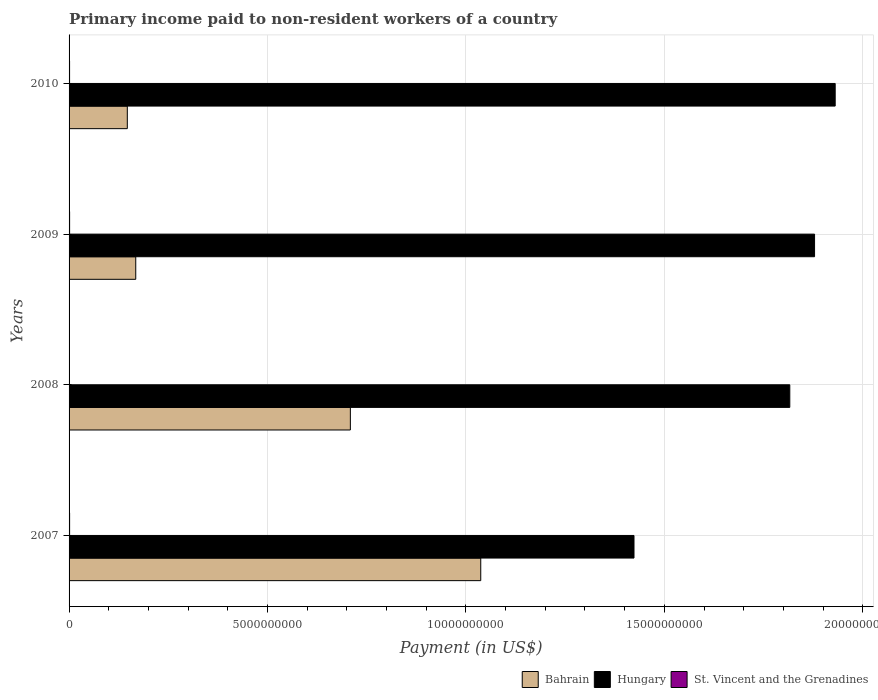Are the number of bars per tick equal to the number of legend labels?
Ensure brevity in your answer.  Yes. Are the number of bars on each tick of the Y-axis equal?
Your answer should be compact. Yes. How many bars are there on the 4th tick from the bottom?
Keep it short and to the point. 3. What is the amount paid to workers in St. Vincent and the Grenadines in 2010?
Provide a short and direct response. 1.27e+07. Across all years, what is the maximum amount paid to workers in St. Vincent and the Grenadines?
Offer a very short reply. 1.37e+07. Across all years, what is the minimum amount paid to workers in Hungary?
Offer a terse response. 1.42e+1. What is the total amount paid to workers in Bahrain in the graph?
Your response must be concise. 2.06e+1. What is the difference between the amount paid to workers in Hungary in 2007 and that in 2008?
Make the answer very short. -3.93e+09. What is the difference between the amount paid to workers in St. Vincent and the Grenadines in 2010 and the amount paid to workers in Hungary in 2008?
Offer a terse response. -1.81e+1. What is the average amount paid to workers in St. Vincent and the Grenadines per year?
Keep it short and to the point. 1.25e+07. In the year 2007, what is the difference between the amount paid to workers in Bahrain and amount paid to workers in St. Vincent and the Grenadines?
Make the answer very short. 1.04e+1. What is the ratio of the amount paid to workers in St. Vincent and the Grenadines in 2007 to that in 2010?
Ensure brevity in your answer.  1.06. Is the amount paid to workers in Bahrain in 2008 less than that in 2010?
Make the answer very short. No. Is the difference between the amount paid to workers in Bahrain in 2007 and 2010 greater than the difference between the amount paid to workers in St. Vincent and the Grenadines in 2007 and 2010?
Make the answer very short. Yes. What is the difference between the highest and the second highest amount paid to workers in St. Vincent and the Grenadines?
Keep it short and to the point. 2.77e+05. What is the difference between the highest and the lowest amount paid to workers in Hungary?
Make the answer very short. 5.07e+09. In how many years, is the amount paid to workers in Hungary greater than the average amount paid to workers in Hungary taken over all years?
Your answer should be very brief. 3. Is the sum of the amount paid to workers in St. Vincent and the Grenadines in 2009 and 2010 greater than the maximum amount paid to workers in Hungary across all years?
Provide a short and direct response. No. What does the 2nd bar from the top in 2010 represents?
Provide a succinct answer. Hungary. What does the 3rd bar from the bottom in 2009 represents?
Ensure brevity in your answer.  St. Vincent and the Grenadines. Is it the case that in every year, the sum of the amount paid to workers in Bahrain and amount paid to workers in St. Vincent and the Grenadines is greater than the amount paid to workers in Hungary?
Provide a short and direct response. No. How many bars are there?
Give a very brief answer. 12. How many years are there in the graph?
Your response must be concise. 4. What is the difference between two consecutive major ticks on the X-axis?
Ensure brevity in your answer.  5.00e+09. Are the values on the major ticks of X-axis written in scientific E-notation?
Provide a short and direct response. No. Does the graph contain grids?
Your answer should be compact. Yes. What is the title of the graph?
Provide a short and direct response. Primary income paid to non-resident workers of a country. What is the label or title of the X-axis?
Provide a succinct answer. Payment (in US$). What is the label or title of the Y-axis?
Make the answer very short. Years. What is the Payment (in US$) in Bahrain in 2007?
Your answer should be compact. 1.04e+1. What is the Payment (in US$) of Hungary in 2007?
Keep it short and to the point. 1.42e+1. What is the Payment (in US$) in St. Vincent and the Grenadines in 2007?
Your answer should be very brief. 1.34e+07. What is the Payment (in US$) in Bahrain in 2008?
Your answer should be compact. 7.09e+09. What is the Payment (in US$) in Hungary in 2008?
Make the answer very short. 1.82e+1. What is the Payment (in US$) of St. Vincent and the Grenadines in 2008?
Your answer should be compact. 1.01e+07. What is the Payment (in US$) of Bahrain in 2009?
Keep it short and to the point. 1.68e+09. What is the Payment (in US$) of Hungary in 2009?
Keep it short and to the point. 1.88e+1. What is the Payment (in US$) of St. Vincent and the Grenadines in 2009?
Your answer should be compact. 1.37e+07. What is the Payment (in US$) of Bahrain in 2010?
Offer a very short reply. 1.47e+09. What is the Payment (in US$) of Hungary in 2010?
Keep it short and to the point. 1.93e+1. What is the Payment (in US$) in St. Vincent and the Grenadines in 2010?
Keep it short and to the point. 1.27e+07. Across all years, what is the maximum Payment (in US$) in Bahrain?
Your response must be concise. 1.04e+1. Across all years, what is the maximum Payment (in US$) of Hungary?
Keep it short and to the point. 1.93e+1. Across all years, what is the maximum Payment (in US$) in St. Vincent and the Grenadines?
Your response must be concise. 1.37e+07. Across all years, what is the minimum Payment (in US$) in Bahrain?
Offer a terse response. 1.47e+09. Across all years, what is the minimum Payment (in US$) of Hungary?
Your answer should be very brief. 1.42e+1. Across all years, what is the minimum Payment (in US$) of St. Vincent and the Grenadines?
Offer a very short reply. 1.01e+07. What is the total Payment (in US$) of Bahrain in the graph?
Your answer should be very brief. 2.06e+1. What is the total Payment (in US$) of Hungary in the graph?
Offer a terse response. 7.05e+1. What is the total Payment (in US$) in St. Vincent and the Grenadines in the graph?
Make the answer very short. 4.99e+07. What is the difference between the Payment (in US$) of Bahrain in 2007 and that in 2008?
Your answer should be very brief. 3.29e+09. What is the difference between the Payment (in US$) in Hungary in 2007 and that in 2008?
Offer a very short reply. -3.93e+09. What is the difference between the Payment (in US$) of St. Vincent and the Grenadines in 2007 and that in 2008?
Your answer should be very brief. 3.29e+06. What is the difference between the Payment (in US$) of Bahrain in 2007 and that in 2009?
Provide a succinct answer. 8.69e+09. What is the difference between the Payment (in US$) in Hungary in 2007 and that in 2009?
Provide a succinct answer. -4.55e+09. What is the difference between the Payment (in US$) of St. Vincent and the Grenadines in 2007 and that in 2009?
Your answer should be compact. -2.77e+05. What is the difference between the Payment (in US$) of Bahrain in 2007 and that in 2010?
Your answer should be very brief. 8.91e+09. What is the difference between the Payment (in US$) in Hungary in 2007 and that in 2010?
Ensure brevity in your answer.  -5.07e+09. What is the difference between the Payment (in US$) in St. Vincent and the Grenadines in 2007 and that in 2010?
Ensure brevity in your answer.  7.36e+05. What is the difference between the Payment (in US$) in Bahrain in 2008 and that in 2009?
Provide a succinct answer. 5.41e+09. What is the difference between the Payment (in US$) of Hungary in 2008 and that in 2009?
Your answer should be very brief. -6.24e+08. What is the difference between the Payment (in US$) of St. Vincent and the Grenadines in 2008 and that in 2009?
Make the answer very short. -3.57e+06. What is the difference between the Payment (in US$) of Bahrain in 2008 and that in 2010?
Your answer should be very brief. 5.62e+09. What is the difference between the Payment (in US$) in Hungary in 2008 and that in 2010?
Offer a terse response. -1.14e+09. What is the difference between the Payment (in US$) in St. Vincent and the Grenadines in 2008 and that in 2010?
Provide a succinct answer. -2.55e+06. What is the difference between the Payment (in US$) of Bahrain in 2009 and that in 2010?
Provide a short and direct response. 2.13e+08. What is the difference between the Payment (in US$) of Hungary in 2009 and that in 2010?
Your answer should be compact. -5.20e+08. What is the difference between the Payment (in US$) of St. Vincent and the Grenadines in 2009 and that in 2010?
Give a very brief answer. 1.01e+06. What is the difference between the Payment (in US$) of Bahrain in 2007 and the Payment (in US$) of Hungary in 2008?
Provide a succinct answer. -7.79e+09. What is the difference between the Payment (in US$) of Bahrain in 2007 and the Payment (in US$) of St. Vincent and the Grenadines in 2008?
Provide a short and direct response. 1.04e+1. What is the difference between the Payment (in US$) of Hungary in 2007 and the Payment (in US$) of St. Vincent and the Grenadines in 2008?
Your answer should be very brief. 1.42e+1. What is the difference between the Payment (in US$) of Bahrain in 2007 and the Payment (in US$) of Hungary in 2009?
Offer a terse response. -8.41e+09. What is the difference between the Payment (in US$) in Bahrain in 2007 and the Payment (in US$) in St. Vincent and the Grenadines in 2009?
Your response must be concise. 1.04e+1. What is the difference between the Payment (in US$) in Hungary in 2007 and the Payment (in US$) in St. Vincent and the Grenadines in 2009?
Your answer should be compact. 1.42e+1. What is the difference between the Payment (in US$) of Bahrain in 2007 and the Payment (in US$) of Hungary in 2010?
Your answer should be very brief. -8.93e+09. What is the difference between the Payment (in US$) of Bahrain in 2007 and the Payment (in US$) of St. Vincent and the Grenadines in 2010?
Offer a terse response. 1.04e+1. What is the difference between the Payment (in US$) of Hungary in 2007 and the Payment (in US$) of St. Vincent and the Grenadines in 2010?
Offer a terse response. 1.42e+1. What is the difference between the Payment (in US$) in Bahrain in 2008 and the Payment (in US$) in Hungary in 2009?
Offer a very short reply. -1.17e+1. What is the difference between the Payment (in US$) of Bahrain in 2008 and the Payment (in US$) of St. Vincent and the Grenadines in 2009?
Provide a succinct answer. 7.07e+09. What is the difference between the Payment (in US$) of Hungary in 2008 and the Payment (in US$) of St. Vincent and the Grenadines in 2009?
Offer a very short reply. 1.81e+1. What is the difference between the Payment (in US$) of Bahrain in 2008 and the Payment (in US$) of Hungary in 2010?
Offer a very short reply. -1.22e+1. What is the difference between the Payment (in US$) of Bahrain in 2008 and the Payment (in US$) of St. Vincent and the Grenadines in 2010?
Keep it short and to the point. 7.08e+09. What is the difference between the Payment (in US$) of Hungary in 2008 and the Payment (in US$) of St. Vincent and the Grenadines in 2010?
Provide a succinct answer. 1.81e+1. What is the difference between the Payment (in US$) of Bahrain in 2009 and the Payment (in US$) of Hungary in 2010?
Provide a short and direct response. -1.76e+1. What is the difference between the Payment (in US$) of Bahrain in 2009 and the Payment (in US$) of St. Vincent and the Grenadines in 2010?
Provide a short and direct response. 1.67e+09. What is the difference between the Payment (in US$) of Hungary in 2009 and the Payment (in US$) of St. Vincent and the Grenadines in 2010?
Provide a succinct answer. 1.88e+1. What is the average Payment (in US$) in Bahrain per year?
Your answer should be very brief. 5.15e+09. What is the average Payment (in US$) in Hungary per year?
Offer a very short reply. 1.76e+1. What is the average Payment (in US$) in St. Vincent and the Grenadines per year?
Your answer should be very brief. 1.25e+07. In the year 2007, what is the difference between the Payment (in US$) of Bahrain and Payment (in US$) of Hungary?
Provide a succinct answer. -3.86e+09. In the year 2007, what is the difference between the Payment (in US$) in Bahrain and Payment (in US$) in St. Vincent and the Grenadines?
Ensure brevity in your answer.  1.04e+1. In the year 2007, what is the difference between the Payment (in US$) in Hungary and Payment (in US$) in St. Vincent and the Grenadines?
Provide a short and direct response. 1.42e+1. In the year 2008, what is the difference between the Payment (in US$) in Bahrain and Payment (in US$) in Hungary?
Your answer should be compact. -1.11e+1. In the year 2008, what is the difference between the Payment (in US$) of Bahrain and Payment (in US$) of St. Vincent and the Grenadines?
Your response must be concise. 7.08e+09. In the year 2008, what is the difference between the Payment (in US$) of Hungary and Payment (in US$) of St. Vincent and the Grenadines?
Provide a short and direct response. 1.82e+1. In the year 2009, what is the difference between the Payment (in US$) of Bahrain and Payment (in US$) of Hungary?
Your response must be concise. -1.71e+1. In the year 2009, what is the difference between the Payment (in US$) in Bahrain and Payment (in US$) in St. Vincent and the Grenadines?
Provide a succinct answer. 1.67e+09. In the year 2009, what is the difference between the Payment (in US$) in Hungary and Payment (in US$) in St. Vincent and the Grenadines?
Give a very brief answer. 1.88e+1. In the year 2010, what is the difference between the Payment (in US$) of Bahrain and Payment (in US$) of Hungary?
Your response must be concise. -1.78e+1. In the year 2010, what is the difference between the Payment (in US$) in Bahrain and Payment (in US$) in St. Vincent and the Grenadines?
Offer a very short reply. 1.45e+09. In the year 2010, what is the difference between the Payment (in US$) of Hungary and Payment (in US$) of St. Vincent and the Grenadines?
Ensure brevity in your answer.  1.93e+1. What is the ratio of the Payment (in US$) of Bahrain in 2007 to that in 2008?
Provide a short and direct response. 1.46. What is the ratio of the Payment (in US$) in Hungary in 2007 to that in 2008?
Give a very brief answer. 0.78. What is the ratio of the Payment (in US$) in St. Vincent and the Grenadines in 2007 to that in 2008?
Offer a very short reply. 1.33. What is the ratio of the Payment (in US$) of Bahrain in 2007 to that in 2009?
Offer a very short reply. 6.17. What is the ratio of the Payment (in US$) in Hungary in 2007 to that in 2009?
Ensure brevity in your answer.  0.76. What is the ratio of the Payment (in US$) of St. Vincent and the Grenadines in 2007 to that in 2009?
Give a very brief answer. 0.98. What is the ratio of the Payment (in US$) in Bahrain in 2007 to that in 2010?
Give a very brief answer. 7.07. What is the ratio of the Payment (in US$) in Hungary in 2007 to that in 2010?
Make the answer very short. 0.74. What is the ratio of the Payment (in US$) in St. Vincent and the Grenadines in 2007 to that in 2010?
Your response must be concise. 1.06. What is the ratio of the Payment (in US$) in Bahrain in 2008 to that in 2009?
Your response must be concise. 4.22. What is the ratio of the Payment (in US$) of Hungary in 2008 to that in 2009?
Your answer should be compact. 0.97. What is the ratio of the Payment (in US$) in St. Vincent and the Grenadines in 2008 to that in 2009?
Ensure brevity in your answer.  0.74. What is the ratio of the Payment (in US$) in Bahrain in 2008 to that in 2010?
Your answer should be very brief. 4.83. What is the ratio of the Payment (in US$) of Hungary in 2008 to that in 2010?
Give a very brief answer. 0.94. What is the ratio of the Payment (in US$) in St. Vincent and the Grenadines in 2008 to that in 2010?
Provide a succinct answer. 0.8. What is the ratio of the Payment (in US$) in Bahrain in 2009 to that in 2010?
Your answer should be compact. 1.14. What is the ratio of the Payment (in US$) in Hungary in 2009 to that in 2010?
Offer a very short reply. 0.97. What is the ratio of the Payment (in US$) in St. Vincent and the Grenadines in 2009 to that in 2010?
Give a very brief answer. 1.08. What is the difference between the highest and the second highest Payment (in US$) in Bahrain?
Your answer should be compact. 3.29e+09. What is the difference between the highest and the second highest Payment (in US$) of Hungary?
Give a very brief answer. 5.20e+08. What is the difference between the highest and the second highest Payment (in US$) of St. Vincent and the Grenadines?
Your answer should be compact. 2.77e+05. What is the difference between the highest and the lowest Payment (in US$) in Bahrain?
Keep it short and to the point. 8.91e+09. What is the difference between the highest and the lowest Payment (in US$) in Hungary?
Provide a succinct answer. 5.07e+09. What is the difference between the highest and the lowest Payment (in US$) in St. Vincent and the Grenadines?
Give a very brief answer. 3.57e+06. 